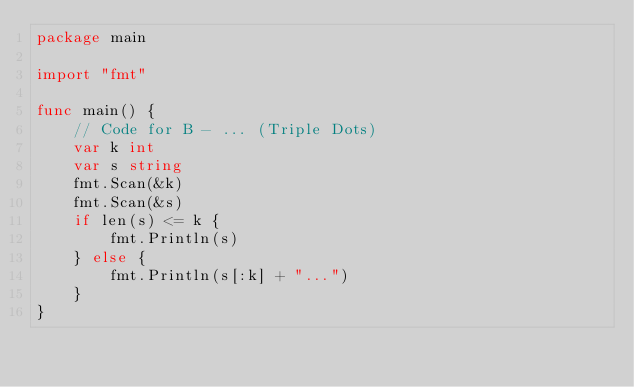<code> <loc_0><loc_0><loc_500><loc_500><_Go_>package main

import "fmt"

func main() {
	// Code for B - ... (Triple Dots)
	var k int
	var s string
	fmt.Scan(&k)
	fmt.Scan(&s)
	if len(s) <= k {
		fmt.Println(s)
	} else {
		fmt.Println(s[:k] + "...")
	}
}
</code> 